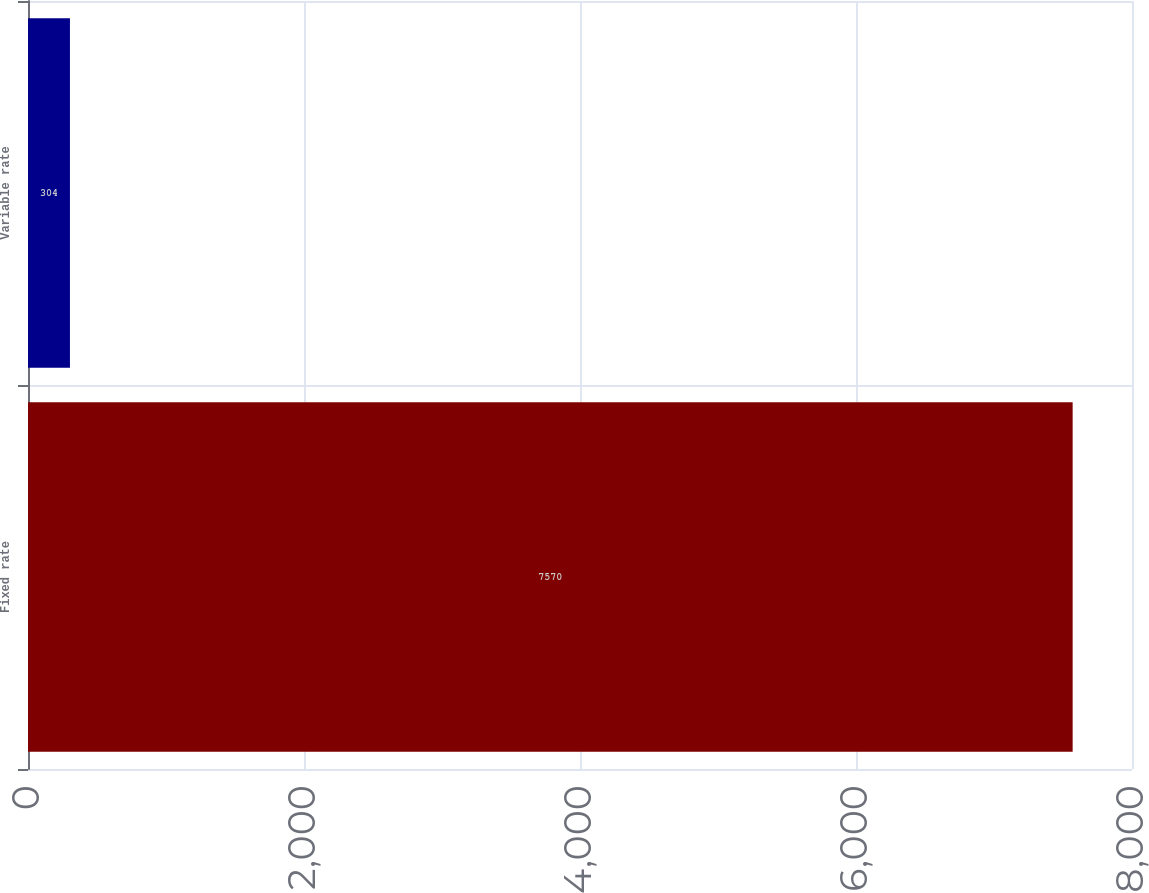Convert chart to OTSL. <chart><loc_0><loc_0><loc_500><loc_500><bar_chart><fcel>Fixed rate<fcel>Variable rate<nl><fcel>7570<fcel>304<nl></chart> 